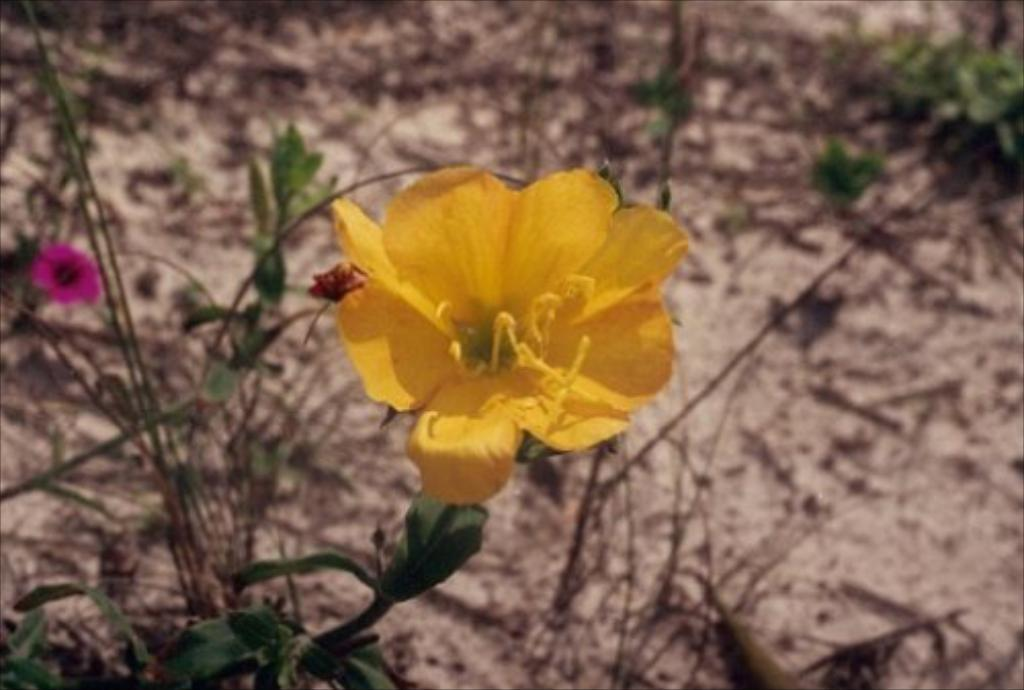What can be seen on the ground in the image? There is a path in the image, and dried twigs are on the path. What type of vegetation is present in the image? There are plants with flowers in the image. What color are the majority of the flowers on the plants? The flowers on the plants are yellow in color. Are there any flowers on the plants that are a different color? Yes, there is at least one flower on the plants that is pink in color. What type of metal is used to make the quiet lunch in the image? There is no mention of metal, lunch, or quietness in the image; it features a path, dried twigs, and plants with flowers. 